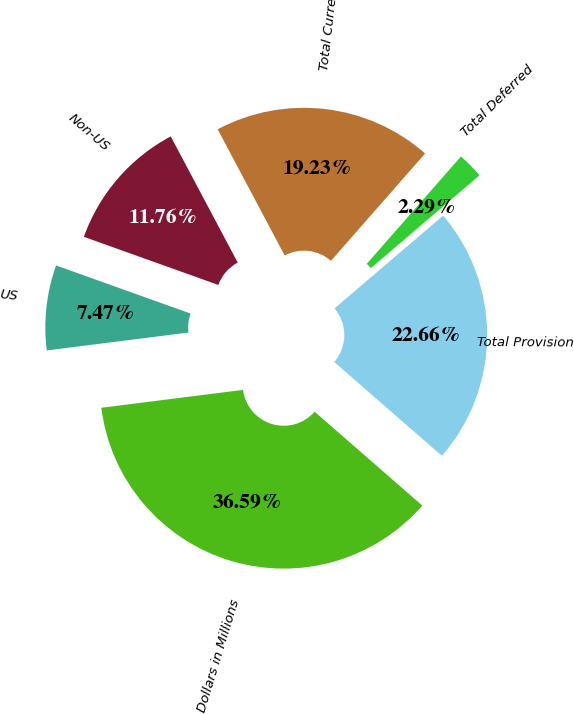<chart> <loc_0><loc_0><loc_500><loc_500><pie_chart><fcel>Dollars in Millions<fcel>US<fcel>Non-US<fcel>Total Current<fcel>Total Deferred<fcel>Total Provision<nl><fcel>36.59%<fcel>7.47%<fcel>11.76%<fcel>19.23%<fcel>2.29%<fcel>22.66%<nl></chart> 